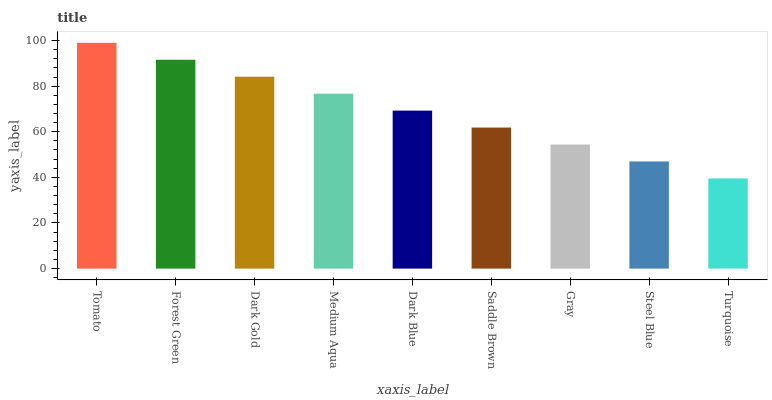Is Turquoise the minimum?
Answer yes or no. Yes. Is Tomato the maximum?
Answer yes or no. Yes. Is Forest Green the minimum?
Answer yes or no. No. Is Forest Green the maximum?
Answer yes or no. No. Is Tomato greater than Forest Green?
Answer yes or no. Yes. Is Forest Green less than Tomato?
Answer yes or no. Yes. Is Forest Green greater than Tomato?
Answer yes or no. No. Is Tomato less than Forest Green?
Answer yes or no. No. Is Dark Blue the high median?
Answer yes or no. Yes. Is Dark Blue the low median?
Answer yes or no. Yes. Is Tomato the high median?
Answer yes or no. No. Is Medium Aqua the low median?
Answer yes or no. No. 